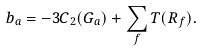Convert formula to latex. <formula><loc_0><loc_0><loc_500><loc_500>b _ { a } = - 3 C _ { 2 } ( G _ { a } ) + \sum _ { f } T ( R _ { f } ) .</formula> 